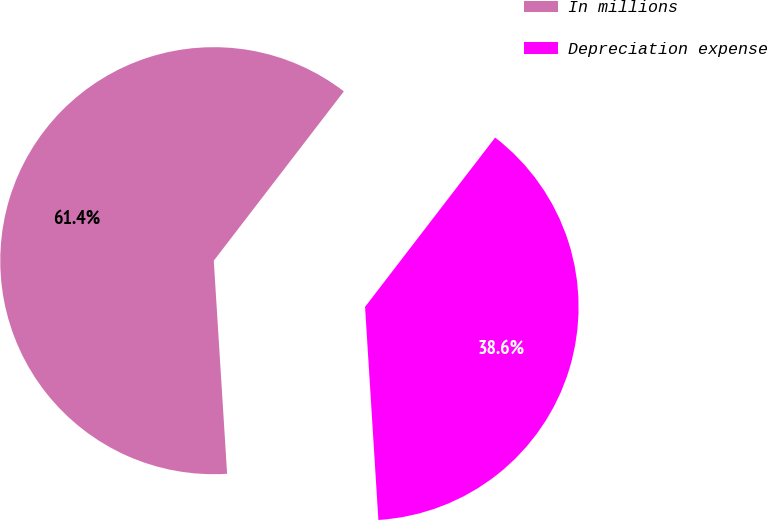<chart> <loc_0><loc_0><loc_500><loc_500><pie_chart><fcel>In millions<fcel>Depreciation expense<nl><fcel>61.42%<fcel>38.58%<nl></chart> 